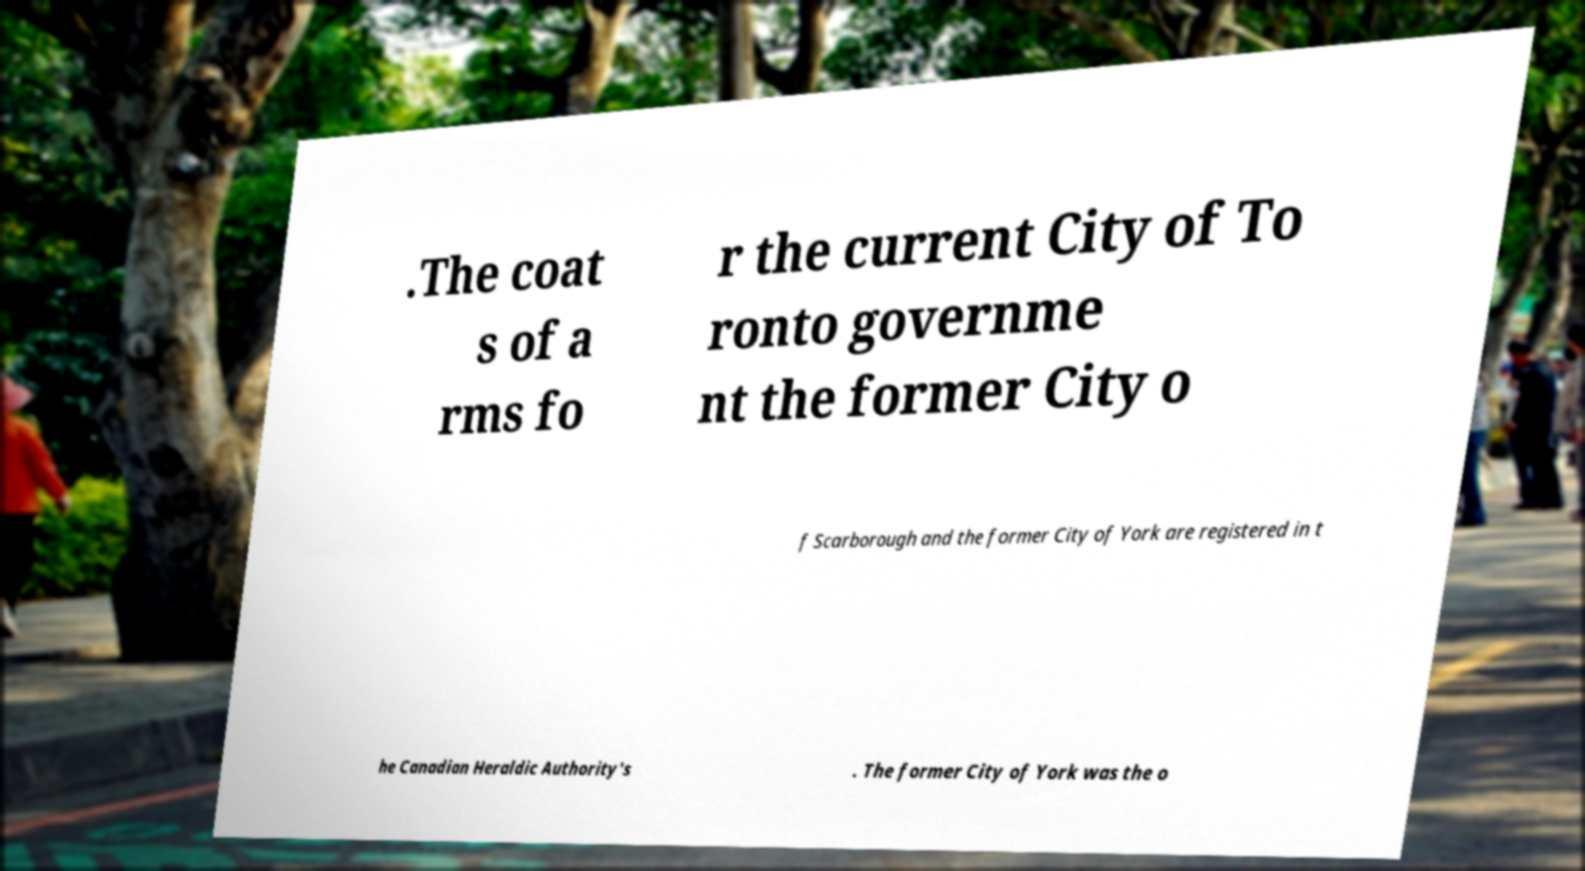What messages or text are displayed in this image? I need them in a readable, typed format. .The coat s of a rms fo r the current City of To ronto governme nt the former City o f Scarborough and the former City of York are registered in t he Canadian Heraldic Authority's . The former City of York was the o 